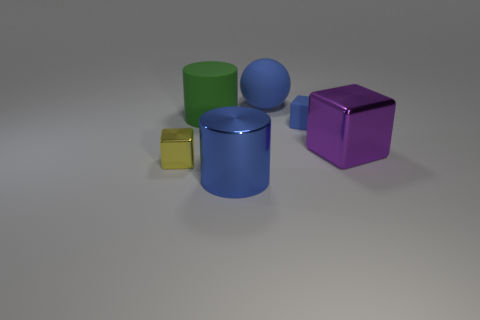Add 2 big blue matte objects. How many objects exist? 8 Subtract all cylinders. How many objects are left? 4 Add 6 large blue metallic cylinders. How many large blue metallic cylinders exist? 7 Subtract 1 yellow blocks. How many objects are left? 5 Subtract all large yellow metallic cubes. Subtract all big matte objects. How many objects are left? 4 Add 6 big rubber spheres. How many big rubber spheres are left? 7 